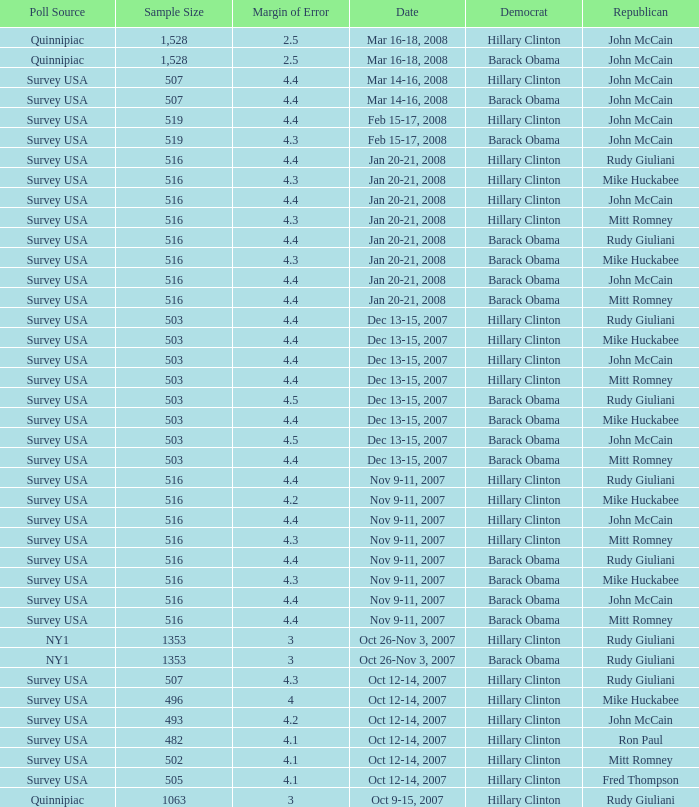What is the sample size of the survey conducted on dec 13-15, 2007 that had a margin of error exceeding 4 and ended with republican mike huckabee? 503.0. 